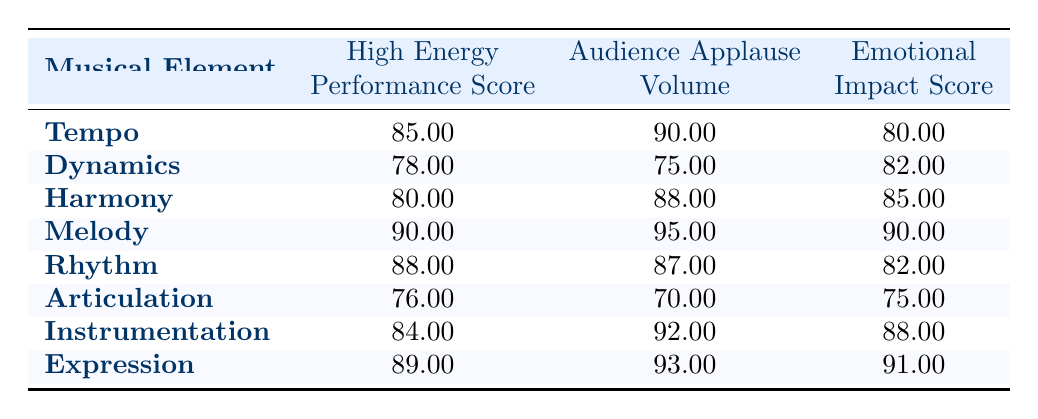What is the High Energy Performance Score for Melody? The table indicates that the High Energy Performance Score for Melody is listed directly next to it, which shows 90.00.
Answer: 90.00 Which musical element has the highest Audience Applause Volume? By scanning the Audience Applause Volume column, it’s evident that Melody, with a score of 95.00, has the highest volume compared to other elements in the list.
Answer: Melody What is the Emotional Impact Score for Articulation? The Emotional Impact Score for Articulation appears in the table as 75.00, which can be directly read from the corresponding row.
Answer: 75.00 How does the High Energy Performance Score of Dynamics compare to that of Instrumentation? The High Energy Performance Score for Dynamics is 78.00 while for Instrumentation it is 84.00. Thus, Instrumentation has a higher score, which shows it scores 6.00 higher than Dynamics.
Answer: Instrumentation scores 6.00 higher What is the average Audience Applause Volume for all musical elements listed? To find the average, I must sum all the Audience Applause Volume values: 90 + 75 + 88 + 95 + 87 + 70 + 92 + 93 = 700. Then I divide this sum by the number of elements (8), thus 700/8 = 87.50, which is the average volume.
Answer: 87.50 Does Harmony have a higher Emotional Impact Score than Rhythm? Harmony's Emotional Impact Score is 85.00 while Rhythm's is 82.00. Therefore, Harmony does indeed have a higher score than Rhythm.
Answer: Yes Which musical element has the lowest High Energy Performance Score? By looking at the High Energy Performance Score column, Articulation has the lowest score at 76.00 when compared to all other musical elements.
Answer: Articulation Is the Emotional Impact Score for Expression higher than that for Dynamics? Taking a look at the Emotional Impact Scores, Expression is at 91.00 while Dynamics is at 82.00. This confirms that Expression has a higher score.
Answer: Yes What is the difference in Audience Applause Volume between the musical elements with the highest and lowest scores? The highest score (Melody at 95.00) and the lowest score (Articulation at 70.00) have a difference of 95.00 - 70.00 = 25.00, indicating the range in audience applause volume.
Answer: 25.00 Which musical element has an Emotional Impact Score of 82.00? In reviewing the table, Dynamics has an Emotional Impact Score of 82.00, matching the specified value from the question.
Answer: Dynamics 